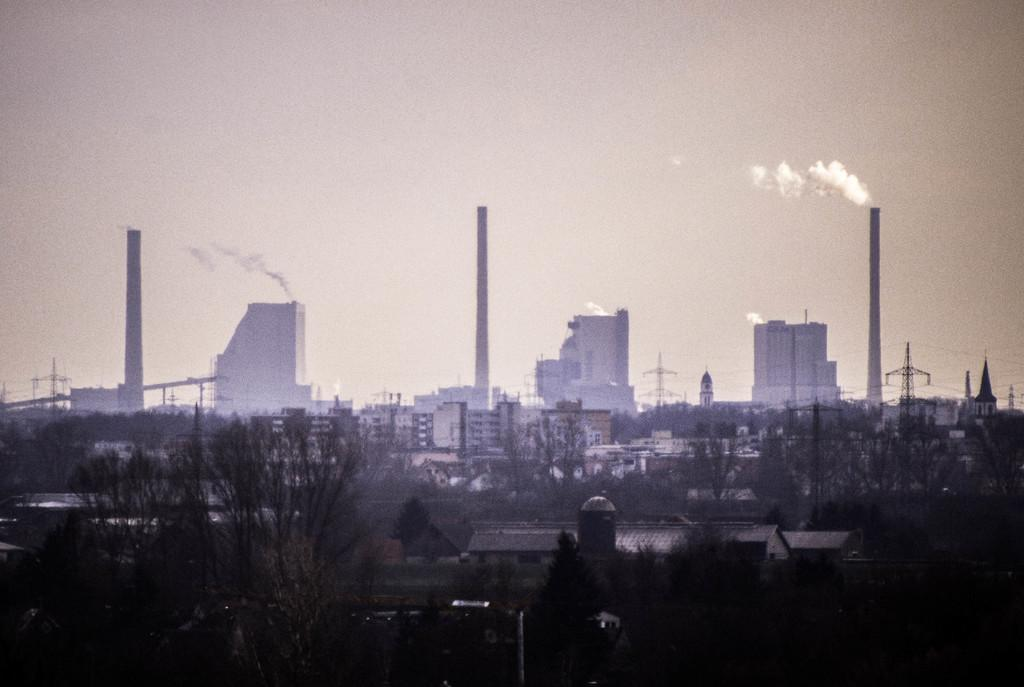What type of structures can be seen in the image? There are buildings and towers in the image. What are some features of the buildings and towers? Wires, windows, and poles are present in the image. What else can be seen in the image besides buildings and towers? Trees are in the image. What is visible in the background of the image? The sky is visible in the background of the image. Can you see an owl flying in the image? There is no owl present in the image. What type of food is the cook preparing in the image? There is no cook present in the image, so it cannot be determined what, if any, food is being prepared. 